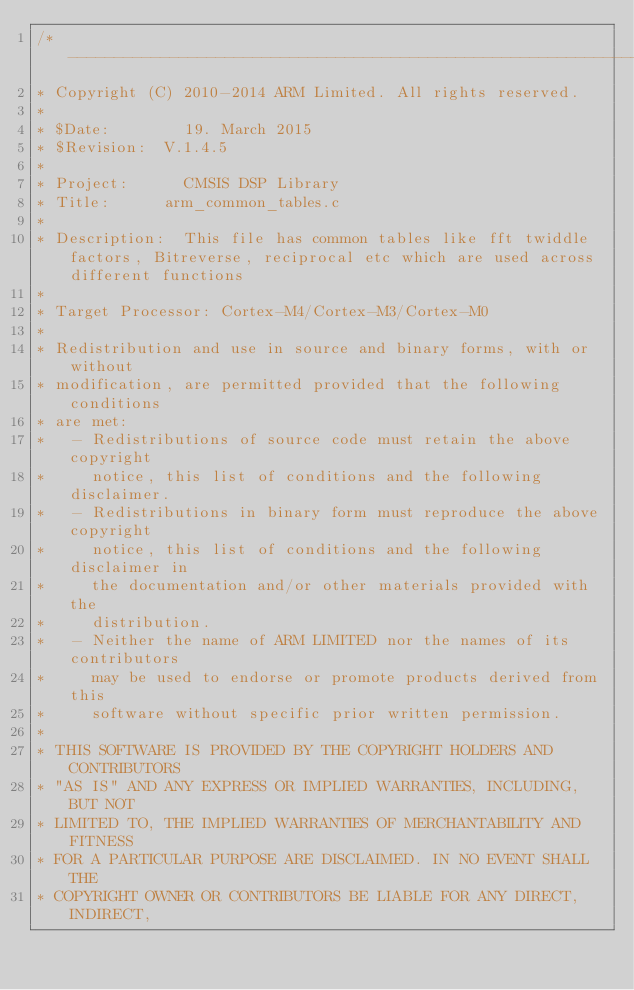Convert code to text. <code><loc_0><loc_0><loc_500><loc_500><_C_>/* ----------------------------------------------------------------------    
* Copyright (C) 2010-2014 ARM Limited. All rights reserved.    
*    
* $Date:        19. March 2015 
* $Revision: 	V.1.4.5  
*    
* Project: 	    CMSIS DSP Library    
* Title:	    arm_common_tables.c    
*    
* Description:	This file has common tables like fft twiddle factors, Bitreverse, reciprocal etc which are used across different functions    
*    
* Target Processor: Cortex-M4/Cortex-M3/Cortex-M0
*  
* Redistribution and use in source and binary forms, with or without 
* modification, are permitted provided that the following conditions
* are met:
*   - Redistributions of source code must retain the above copyright
*     notice, this list of conditions and the following disclaimer.
*   - Redistributions in binary form must reproduce the above copyright
*     notice, this list of conditions and the following disclaimer in
*     the documentation and/or other materials provided with the 
*     distribution.
*   - Neither the name of ARM LIMITED nor the names of its contributors
*     may be used to endorse or promote products derived from this
*     software without specific prior written permission.
*
* THIS SOFTWARE IS PROVIDED BY THE COPYRIGHT HOLDERS AND CONTRIBUTORS
* "AS IS" AND ANY EXPRESS OR IMPLIED WARRANTIES, INCLUDING, BUT NOT
* LIMITED TO, THE IMPLIED WARRANTIES OF MERCHANTABILITY AND FITNESS
* FOR A PARTICULAR PURPOSE ARE DISCLAIMED. IN NO EVENT SHALL THE 
* COPYRIGHT OWNER OR CONTRIBUTORS BE LIABLE FOR ANY DIRECT, INDIRECT,</code> 